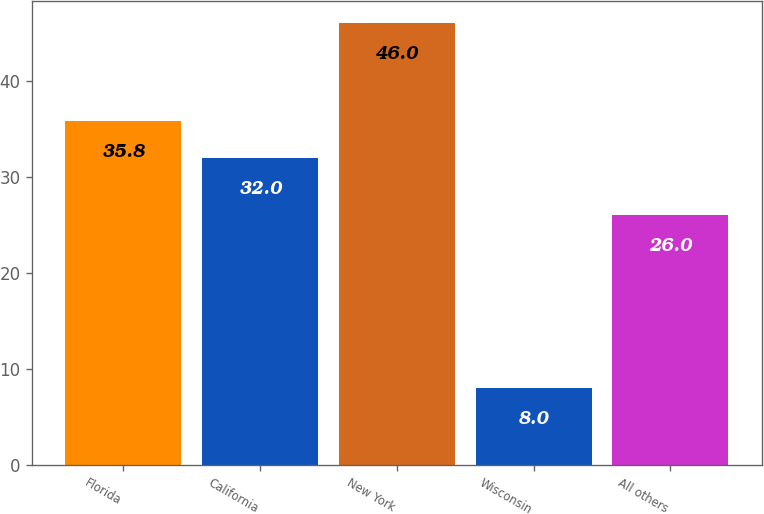<chart> <loc_0><loc_0><loc_500><loc_500><bar_chart><fcel>Florida<fcel>California<fcel>New York<fcel>Wisconsin<fcel>All others<nl><fcel>35.8<fcel>32<fcel>46<fcel>8<fcel>26<nl></chart> 